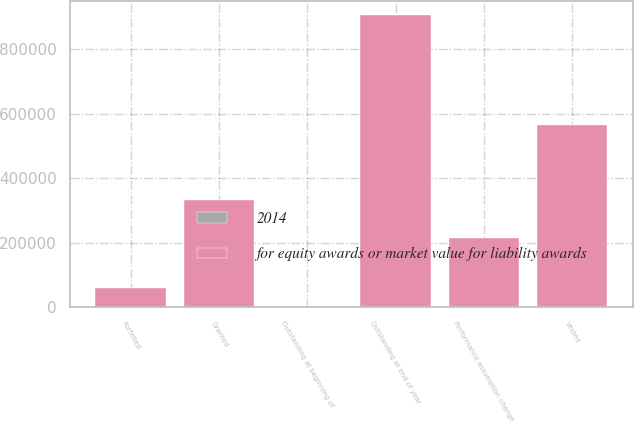Convert chart. <chart><loc_0><loc_0><loc_500><loc_500><stacked_bar_chart><ecel><fcel>Outstanding at beginning of<fcel>Granted<fcel>Performance assumption change<fcel>Vested<fcel>Forfeited<fcel>Outstanding at end of year<nl><fcel>for equity awards or market value for liability awards<fcel>115.57<fcel>331788<fcel>214145<fcel>565520<fcel>59216<fcel>904306<nl><fcel>2014<fcel>72.43<fcel>115.57<fcel>91.85<fcel>63.93<fcel>95.86<fcel>94.48<nl></chart> 